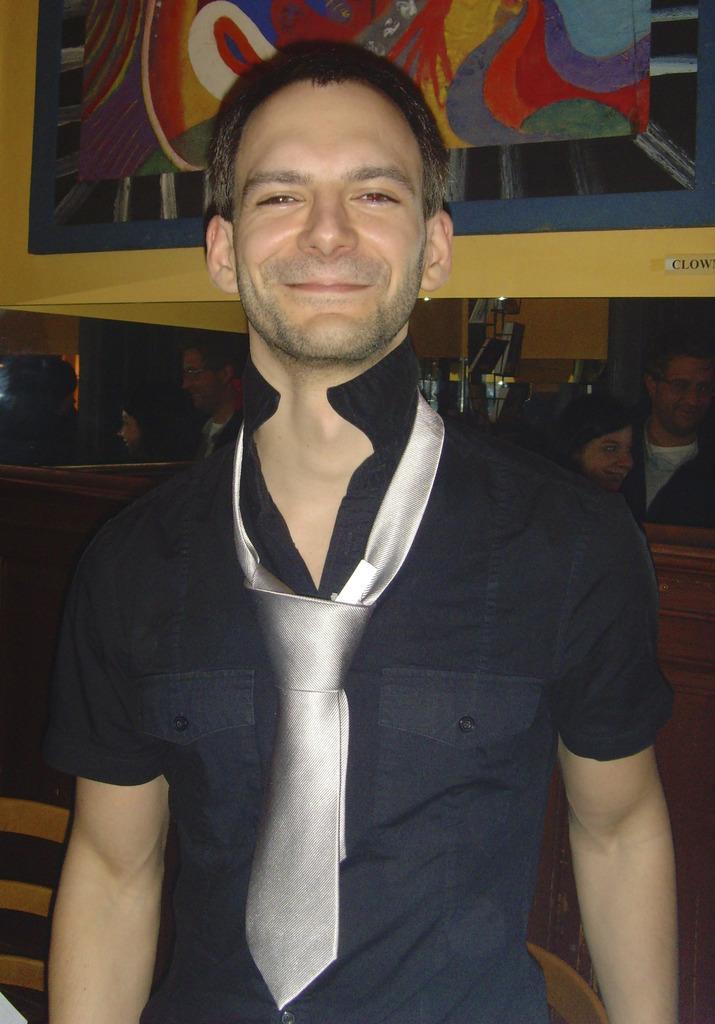Please provide a concise description of this image. In this image we can see a few people, one of them is wearing a tie, there is the painting on the wall. 